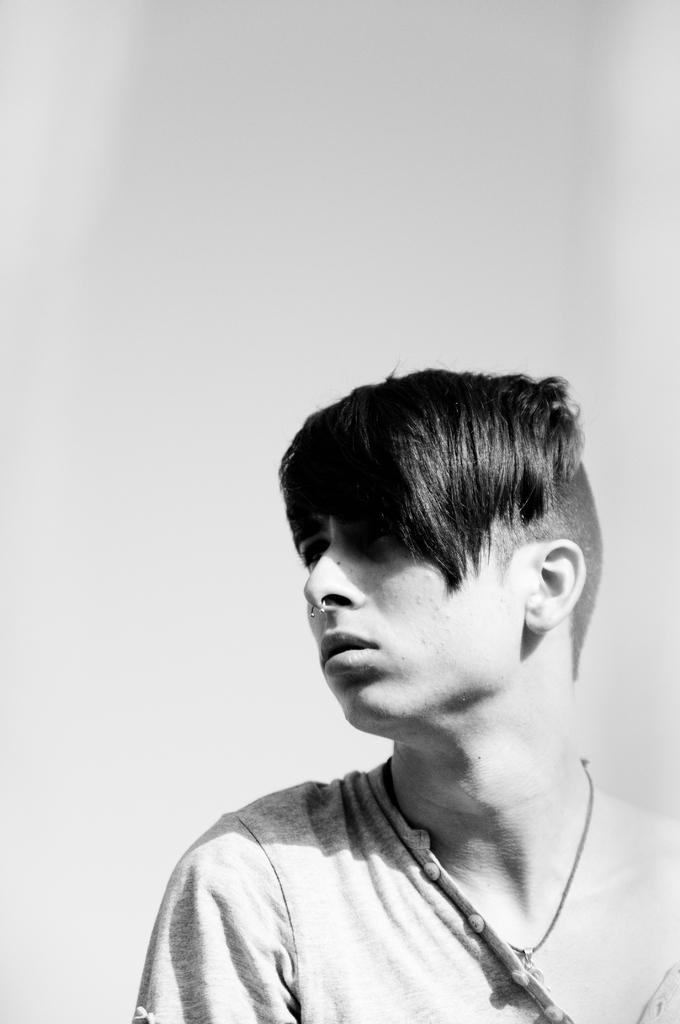What is the color scheme of the photograph? The photograph is black and white. Who is the main subject of the photograph? The subject of the photograph is a boy. Can you describe the boy's hairstyle? The boy has a hairstyle with a bald part. What type of clothing is the boy wearing? The boy is wearing a T-shirt with buttons. What channel is the boy watching on the television in the image? There is no television present in the image, so it is not possible to determine what channel the boy might be watching. 